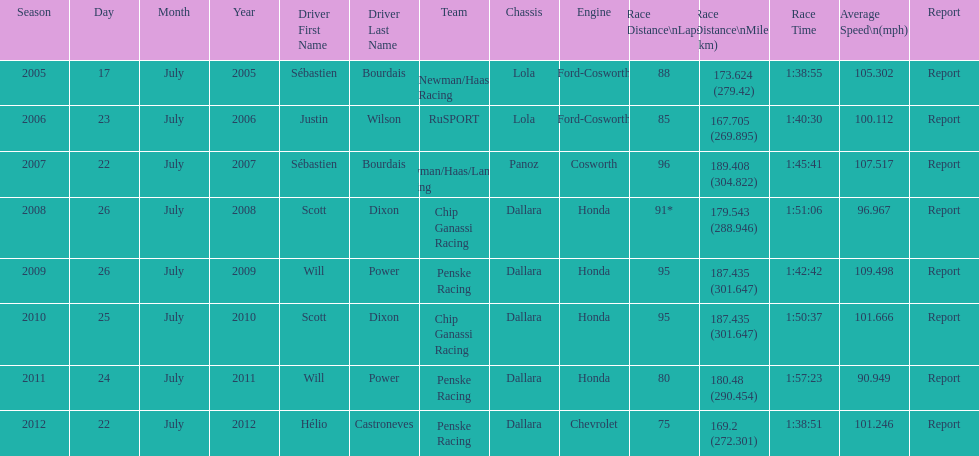What is the total number dallara chassis listed in the table? 5. 